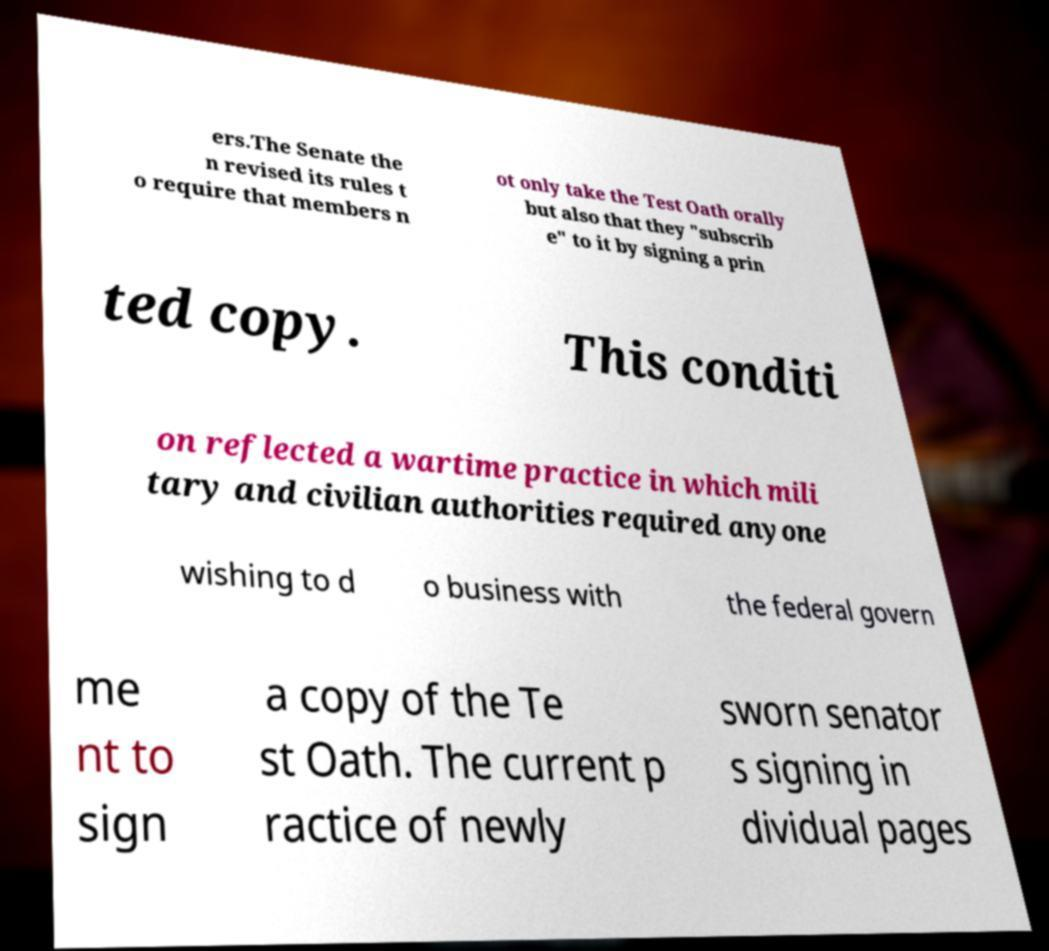What messages or text are displayed in this image? I need them in a readable, typed format. ers.The Senate the n revised its rules t o require that members n ot only take the Test Oath orally but also that they "subscrib e" to it by signing a prin ted copy. This conditi on reflected a wartime practice in which mili tary and civilian authorities required anyone wishing to d o business with the federal govern me nt to sign a copy of the Te st Oath. The current p ractice of newly sworn senator s signing in dividual pages 